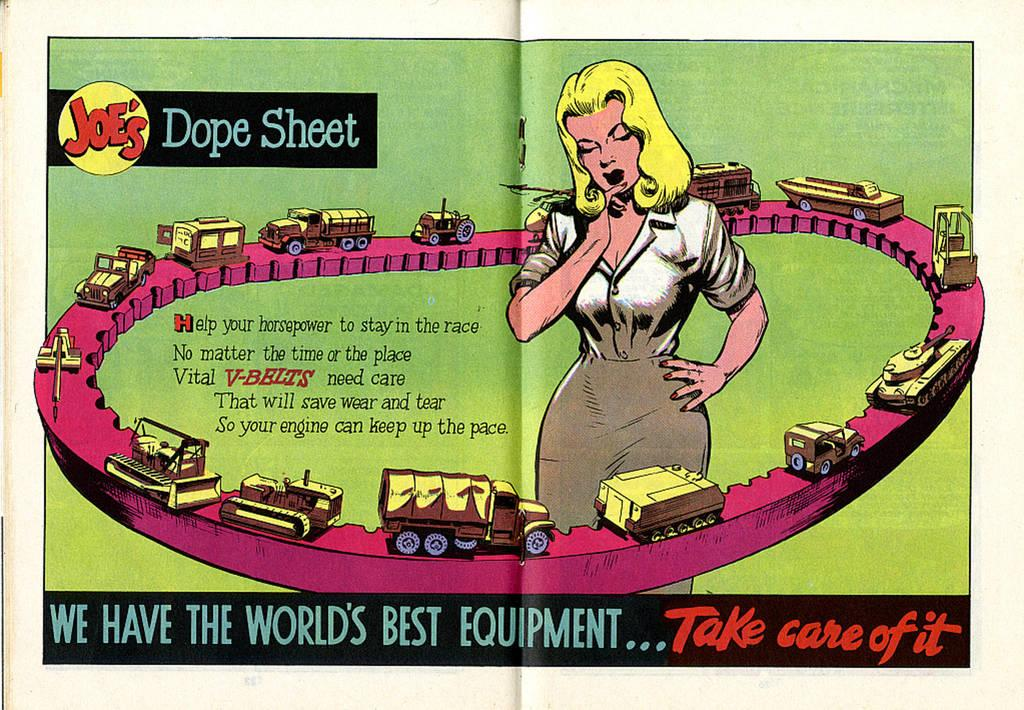<image>
Render a clear and concise summary of the photo. a magazine with take care of it written in it 